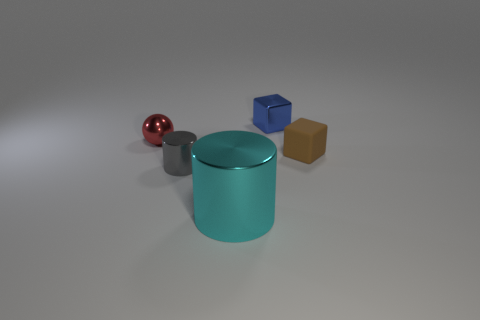Add 2 large cyan metallic things. How many objects exist? 7 Subtract all cylinders. How many objects are left? 3 Add 5 tiny brown cubes. How many tiny brown cubes exist? 6 Subtract 1 brown blocks. How many objects are left? 4 Subtract all small brown rubber objects. Subtract all large purple blocks. How many objects are left? 4 Add 5 small gray things. How many small gray things are left? 6 